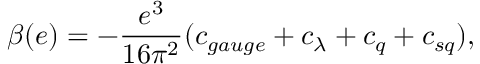Convert formula to latex. <formula><loc_0><loc_0><loc_500><loc_500>\beta ( e ) = - \frac { e ^ { 3 } } { 1 6 \pi ^ { 2 } } ( c _ { g a u g e } + c _ { \lambda } + c _ { q } + c _ { s q } ) ,</formula> 